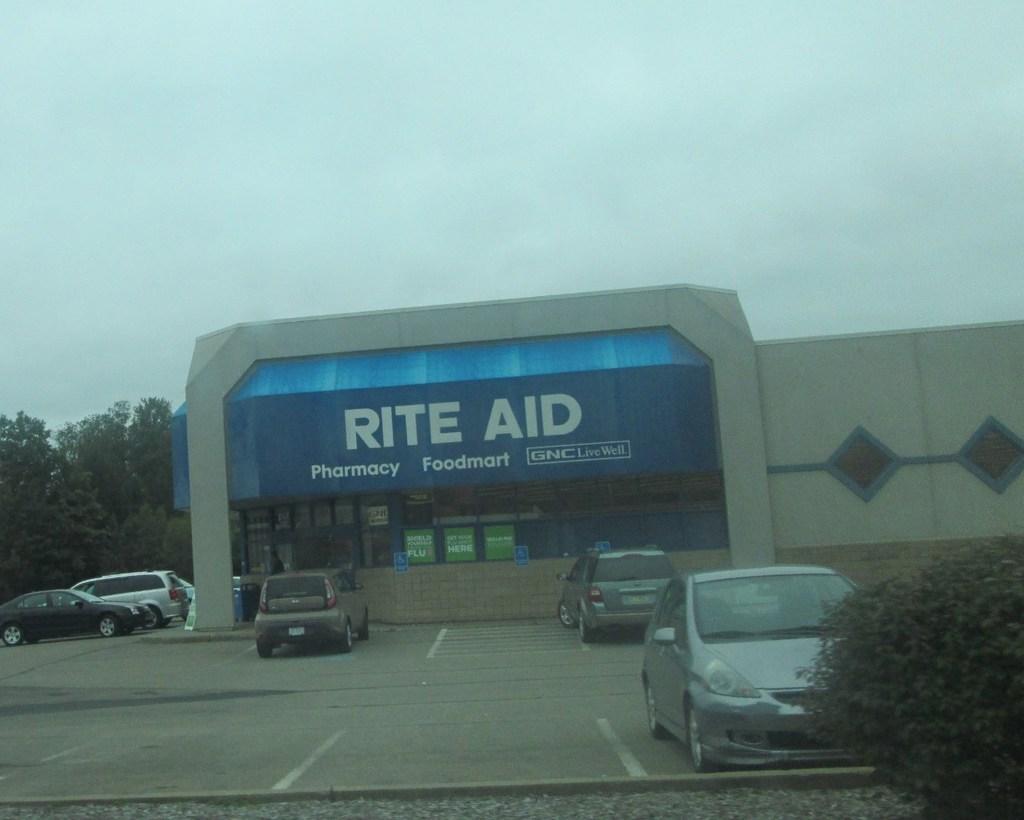Could you give a brief overview of what you see in this image? This picture shows a building and we see few cars parked and trees and we see a name board on the building and a cloudy Sky. 